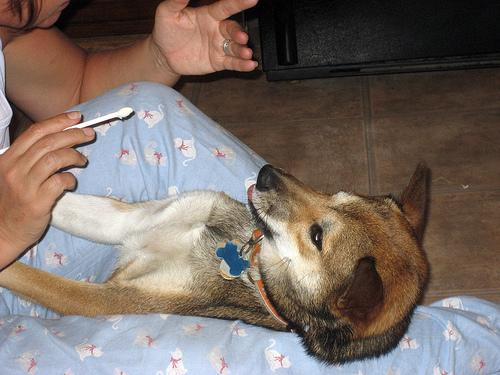Question: where do you see a ring?
Choices:
A. On the lady's right hand.
B. On the lady's left hand.
C. In the lady's nose.
D. On the man's left hand.
Answer with the letter. Answer: B Question: what hand is the girl holding a white stick in?
Choices:
A. Left.
B. Right.
C. Dominant hand.
D. Non-dominant hand.
Answer with the letter. Answer: B Question: what kind of floor are they sitting on?
Choices:
A. Tile Floor.
B. Wood floor.
C. Marble floor.
D. Brick floor.
Answer with the letter. Answer: A Question: where is the dog sitting?
Choices:
A. In the girl's lap.
B. On the floor.
C. On the bed.
D. In the chair.
Answer with the letter. Answer: A 